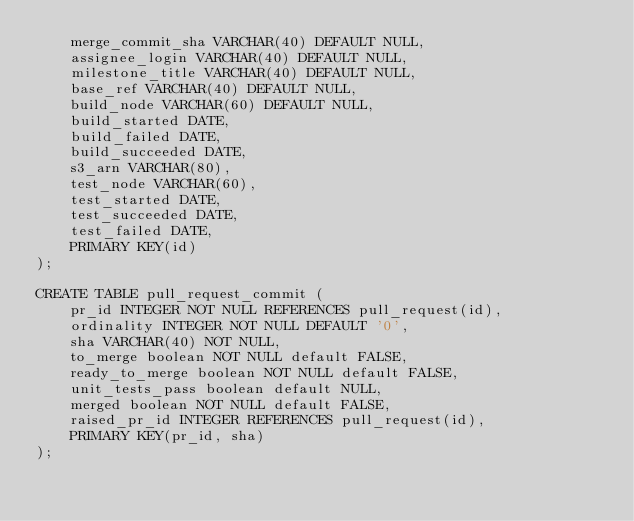Convert code to text. <code><loc_0><loc_0><loc_500><loc_500><_SQL_>    merge_commit_sha VARCHAR(40) DEFAULT NULL,
    assignee_login VARCHAR(40) DEFAULT NULL,
    milestone_title VARCHAR(40) DEFAULT NULL,
    base_ref VARCHAR(40) DEFAULT NULL,
    build_node VARCHAR(60) DEFAULT NULL,
    build_started DATE,
    build_failed DATE,
    build_succeeded DATE,
    s3_arn VARCHAR(80),
    test_node VARCHAR(60),
    test_started DATE,
    test_succeeded DATE,
    test_failed DATE,
    PRIMARY KEY(id)
);

CREATE TABLE pull_request_commit (
    pr_id INTEGER NOT NULL REFERENCES pull_request(id),
    ordinality INTEGER NOT NULL DEFAULT '0',
    sha VARCHAR(40) NOT NULL,
    to_merge boolean NOT NULL default FALSE,
    ready_to_merge boolean NOT NULL default FALSE,
    unit_tests_pass boolean default NULL,
    merged boolean NOT NULL default FALSE,
    raised_pr_id INTEGER REFERENCES pull_request(id),
    PRIMARY KEY(pr_id, sha)
);
</code> 